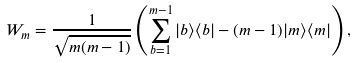Convert formula to latex. <formula><loc_0><loc_0><loc_500><loc_500>W _ { m } = \frac { 1 } { \sqrt { m ( m - 1 ) } } \left ( \sum _ { b = 1 } ^ { m - 1 } | b \rangle \langle b | - ( m - 1 ) | m \rangle \langle m | \right ) ,</formula> 